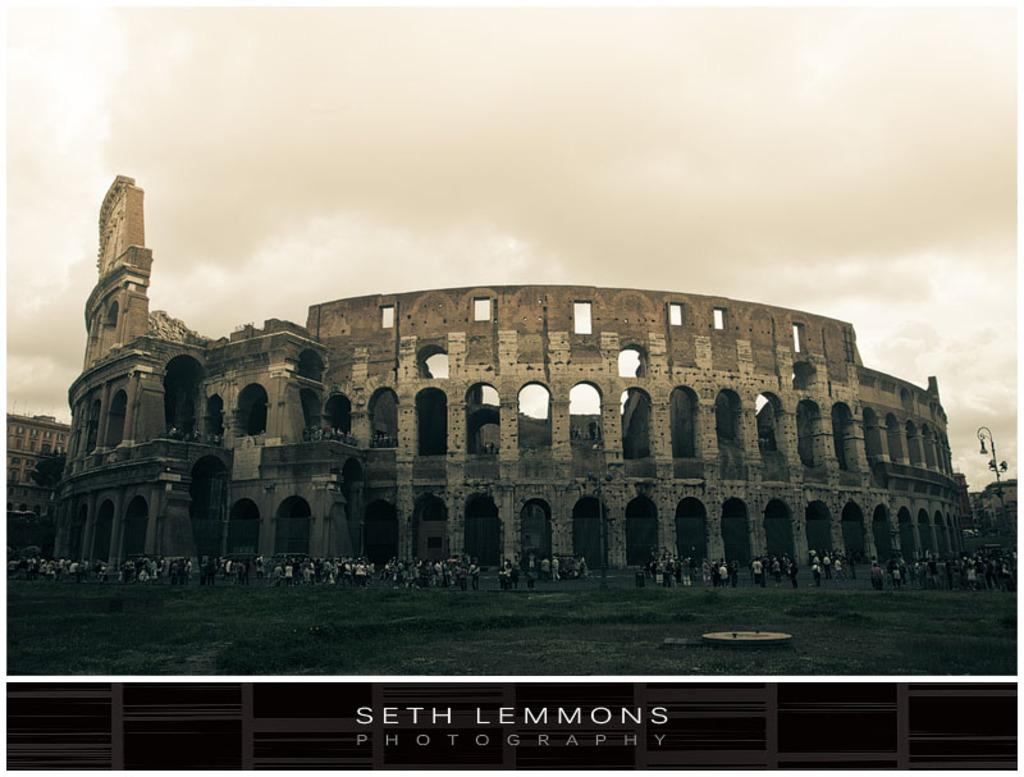What type of vegetation can be seen in the image? There are trees and grass in the image. What structures are present in the image? There are poles in the image. Are there any people in the image? Yes, there are people in the image. What is visible in the background of the image? The sky is visible in the background of the image, and there are clouds in the sky. Is there any text present in the image? Yes, there is text written at the bottom of the image. How many rings can be seen on the boot in the image? There is no boot present in the image, and therefore no rings can be seen. What type of downtown area is visible in the image? There is no downtown area visible in the image; it features trees, grass, poles, people, and the sky. 